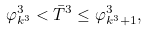<formula> <loc_0><loc_0><loc_500><loc_500>\varphi ^ { 3 } _ { k ^ { 3 } } < \bar { T } ^ { 3 } \leq \varphi ^ { 3 } _ { k ^ { 3 } + 1 } ,</formula> 